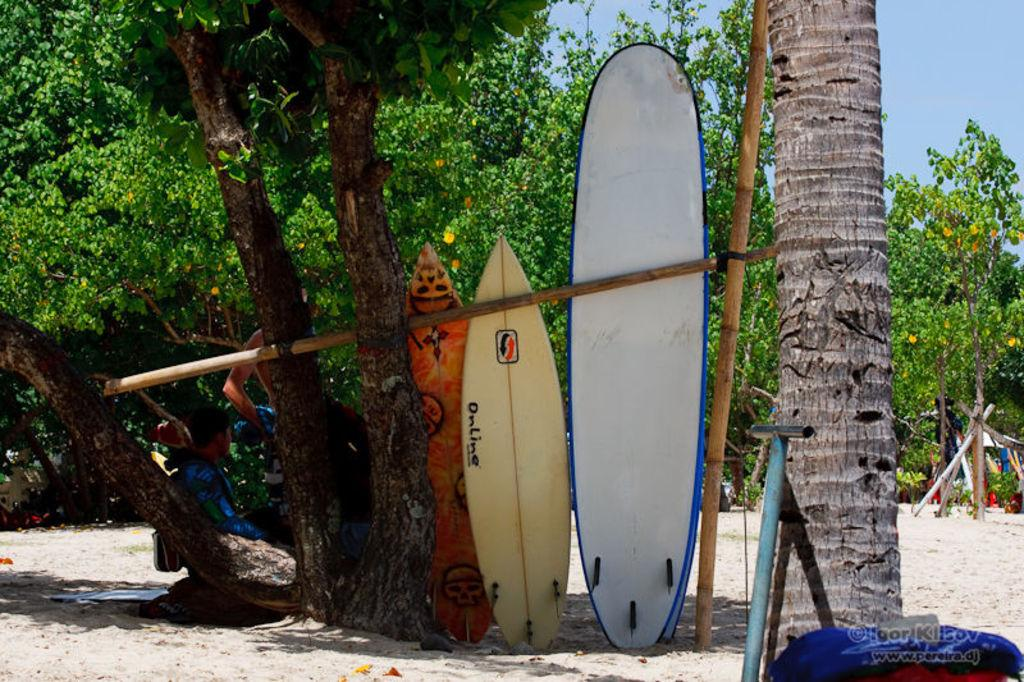What objects are located beside the tree trunk in the image? There are surfing boards beside the tree trunk in the image. What can be seen in the background of the image? There are many trees in the background of the image. What type of music is being played in the background of the image? There is no indication of music being played in the image; it only features surfing boards and trees. 